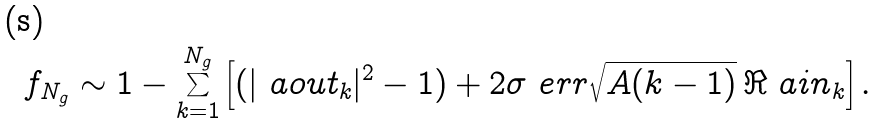<formula> <loc_0><loc_0><loc_500><loc_500>f _ { N _ { g } } \sim 1 - \sum _ { k = 1 } ^ { N _ { g } } \left [ ( | \ a o u t _ { k } | ^ { 2 } - 1 ) + 2 \sigma _ { \ } e r r \sqrt { A ( k - 1 ) } \, \Re \ a i n _ { k } \right ] .</formula> 